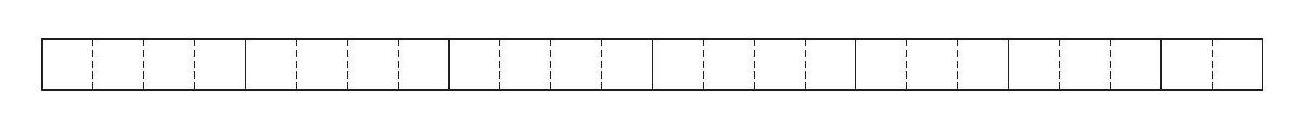A rectangle with length $24 \mathrm{~m}$ and width $1 \mathrm{~m}$ is cut into smaller rectangles, each with width $1 \mathrm{~m}$. There are four pieces with length $4 \mathrm{~m}$, two pieces with length $3 \mathrm{~m}$ and one piece with length $2 \mathrm{~m}$. These smaller rectangles are put together to form another rectangle. What is the smallest possible perimeter of the new rectangle? To find the smallest possible perimeter of a new rectangle made from smaller rectangles, we must arrange them to minimize the combined length and width. The given pieces are four $4 \mathrm{~m}$ lengths, two $3 \mathrm{~m}$ lengths, and one $2 \mathrm{~m}$ length, all with width $1 \mathrm{~m}$. By combining the pieces, we get a total length of $4*4 + 2*3 + 1*2 = 26 \mathrm{~m}$. The smallest perimeter would be achieved by forming a rectangle that is as close to a square as possible. The closest we can get with these lengths is a $6 \mathrm{~m} \times 4 \mathrm{~m}$ rectangle, giving us a perimeter of $2*(6+4) = 20 \mathrm{~m}$. Thus, the smallest possible perimeter of the new rectangle is $20 \mathrm{~m}$. 